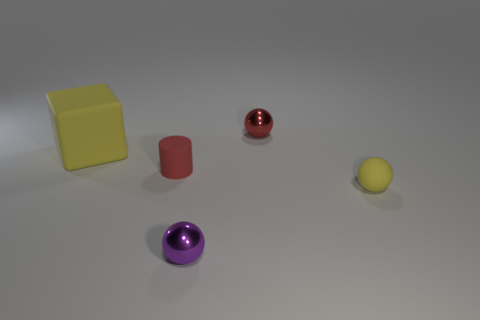Add 5 large gray shiny objects. How many objects exist? 10 Subtract all cylinders. How many objects are left? 4 Subtract all shiny spheres. Subtract all small cyan metallic spheres. How many objects are left? 3 Add 4 blocks. How many blocks are left? 5 Add 2 yellow matte cylinders. How many yellow matte cylinders exist? 2 Subtract 1 red spheres. How many objects are left? 4 